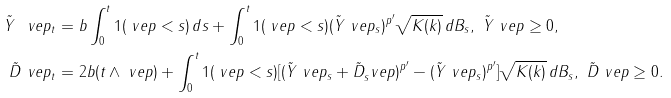<formula> <loc_0><loc_0><loc_500><loc_500>\tilde { Y } ^ { \ } v e p _ { t } & = b \int _ { 0 } ^ { t } 1 ( \ v e p < s ) \, d s + \int _ { 0 } ^ { t } 1 ( \ v e p < s ) ( \tilde { Y } ^ { \ } v e p _ { s } ) ^ { p ^ { \prime } } \sqrt { K ( k ) } \, d B _ { s } , \ \tilde { Y } ^ { \ } v e p \geq 0 , \\ \tilde { D } ^ { \ } v e p _ { t } & = 2 b ( t \wedge \ v e p ) + \int _ { 0 } ^ { t } 1 ( \ v e p < s ) [ ( \tilde { Y } ^ { \ } v e p _ { s } + \tilde { D } _ { s } ^ { \ } v e p ) ^ { p ^ { \prime } } - ( \tilde { Y } ^ { \ } v e p _ { s } ) ^ { p ^ { \prime } } ] \sqrt { K ( k ) } \, d B _ { s } , \ \tilde { D } ^ { \ } v e p \geq 0 .</formula> 